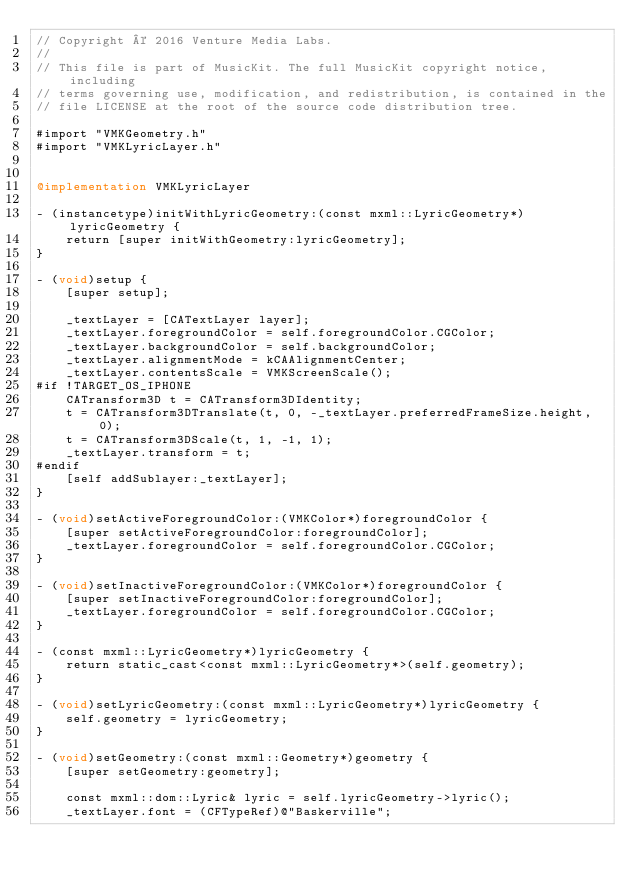<code> <loc_0><loc_0><loc_500><loc_500><_ObjectiveC_>// Copyright © 2016 Venture Media Labs.
//
// This file is part of MusicKit. The full MusicKit copyright notice, including
// terms governing use, modification, and redistribution, is contained in the
// file LICENSE at the root of the source code distribution tree.

#import "VMKGeometry.h"
#import "VMKLyricLayer.h"


@implementation VMKLyricLayer

- (instancetype)initWithLyricGeometry:(const mxml::LyricGeometry*)lyricGeometry {
    return [super initWithGeometry:lyricGeometry];
}

- (void)setup {
    [super setup];

    _textLayer = [CATextLayer layer];
    _textLayer.foregroundColor = self.foregroundColor.CGColor;
    _textLayer.backgroundColor = self.backgroundColor;
    _textLayer.alignmentMode = kCAAlignmentCenter;
    _textLayer.contentsScale = VMKScreenScale();
#if !TARGET_OS_IPHONE
    CATransform3D t = CATransform3DIdentity;
    t = CATransform3DTranslate(t, 0, -_textLayer.preferredFrameSize.height, 0);
    t = CATransform3DScale(t, 1, -1, 1);
    _textLayer.transform = t;
#endif
    [self addSublayer:_textLayer];
}

- (void)setActiveForegroundColor:(VMKColor*)foregroundColor {
    [super setActiveForegroundColor:foregroundColor];
    _textLayer.foregroundColor = self.foregroundColor.CGColor;
}

- (void)setInactiveForegroundColor:(VMKColor*)foregroundColor {
    [super setInactiveForegroundColor:foregroundColor];
    _textLayer.foregroundColor = self.foregroundColor.CGColor;
}

- (const mxml::LyricGeometry*)lyricGeometry {
    return static_cast<const mxml::LyricGeometry*>(self.geometry);
}

- (void)setLyricGeometry:(const mxml::LyricGeometry*)lyricGeometry {
    self.geometry = lyricGeometry;
}

- (void)setGeometry:(const mxml::Geometry*)geometry {
    [super setGeometry:geometry];

    const mxml::dom::Lyric& lyric = self.lyricGeometry->lyric();
    _textLayer.font = (CFTypeRef)@"Baskerville";</code> 